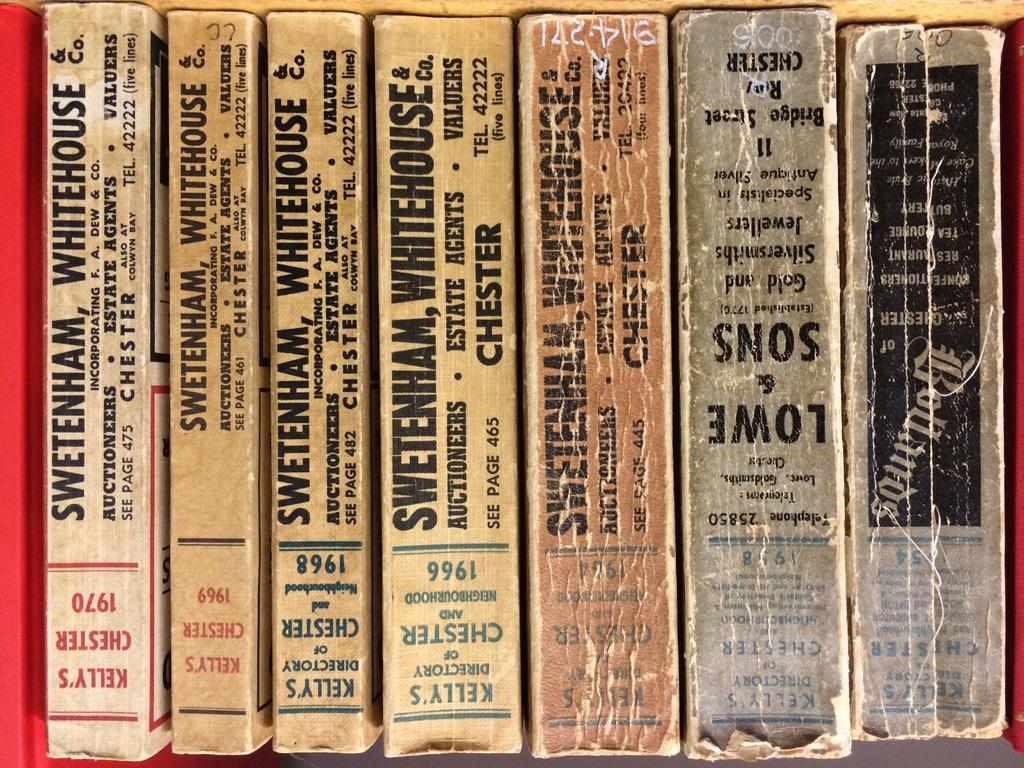<image>
Create a compact narrative representing the image presented. A row of books by Swetenham, Whitehouse & Co. 